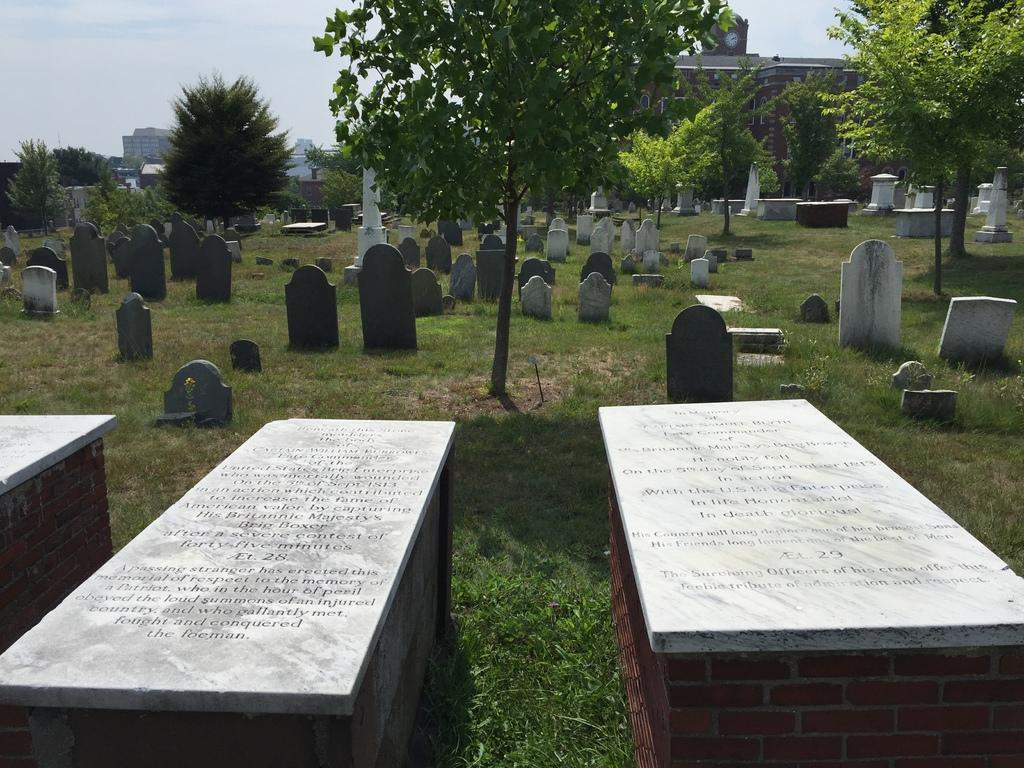What type of structures can be seen in the image? There are cemeteries in the image. Where are the cemeteries located? The cemeteries are located in a graveyard. What type of vegetation is present in the image? There are trees in the image. Where are the trees located in relation to the cemeteries? The trees are located behind the cemeteries. What can be seen in the background of the image? There is a building visible in the background of the image. What type of bean is growing on the cemeteries in the image? There are no beans growing on the cemeteries in the image; they are located in a graveyard. 